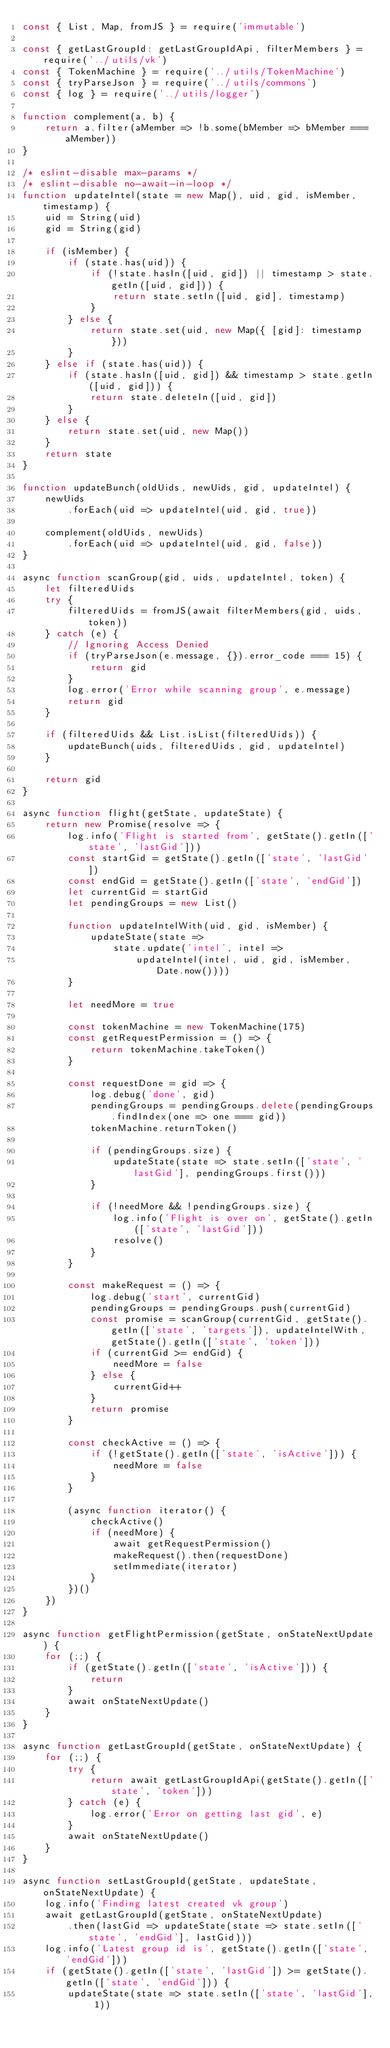<code> <loc_0><loc_0><loc_500><loc_500><_JavaScript_>const { List, Map, fromJS } = require('immutable')

const { getLastGroupId: getLastGroupIdApi, filterMembers } = require('../utils/vk')
const { TokenMachine } = require('../utils/TokenMachine')
const { tryParseJson } = require('../utils/commons')
const { log } = require('../utils/logger')

function complement(a, b) {
    return a.filter(aMember => !b.some(bMember => bMember === aMember))
}

/* eslint-disable max-params */
/* eslint-disable no-await-in-loop */
function updateIntel(state = new Map(), uid, gid, isMember, timestamp) {
    uid = String(uid)
    gid = String(gid)

    if (isMember) {
        if (state.has(uid)) {
            if (!state.hasIn([uid, gid]) || timestamp > state.getIn([uid, gid])) {
                return state.setIn([uid, gid], timestamp)
            }
        } else {
            return state.set(uid, new Map({ [gid]: timestamp }))
        }
    } else if (state.has(uid)) {
        if (state.hasIn([uid, gid]) && timestamp > state.getIn([uid, gid])) {
            return state.deleteIn([uid, gid])
        }
    } else {
        return state.set(uid, new Map())
    }
    return state
}

function updateBunch(oldUids, newUids, gid, updateIntel) {
    newUids
        .forEach(uid => updateIntel(uid, gid, true))

    complement(oldUids, newUids)
        .forEach(uid => updateIntel(uid, gid, false))
}

async function scanGroup(gid, uids, updateIntel, token) {
    let filteredUids
    try {
        filteredUids = fromJS(await filterMembers(gid, uids, token))
    } catch (e) {
        // Ignoring Access Denied
        if (tryParseJson(e.message, {}).error_code === 15) {
            return gid
        }
        log.error('Error while scanning group', e.message)
        return gid
    }

    if (filteredUids && List.isList(filteredUids)) {
        updateBunch(uids, filteredUids, gid, updateIntel)
    }

    return gid
}

async function flight(getState, updateState) {
    return new Promise(resolve => {
        log.info('Flight is started from', getState().getIn(['state', 'lastGid']))
        const startGid = getState().getIn(['state', 'lastGid'])
        const endGid = getState().getIn(['state', 'endGid'])
        let currentGid = startGid
        let pendingGroups = new List()

        function updateIntelWith(uid, gid, isMember) {
            updateState(state =>
                state.update('intel', intel =>
                    updateIntel(intel, uid, gid, isMember, Date.now())))
        }

        let needMore = true

        const tokenMachine = new TokenMachine(175)
        const getRequestPermission = () => {
            return tokenMachine.takeToken()
        }

        const requestDone = gid => {
            log.debug('done', gid)
            pendingGroups = pendingGroups.delete(pendingGroups.findIndex(one => one === gid))
            tokenMachine.returnToken()

            if (pendingGroups.size) {
                updateState(state => state.setIn(['state', 'lastGid'], pendingGroups.first()))
            }

            if (!needMore && !pendingGroups.size) {
                log.info('Flight is over on', getState().getIn(['state', 'lastGid']))
                resolve()
            }
        }

        const makeRequest = () => {
            log.debug('start', currentGid)
            pendingGroups = pendingGroups.push(currentGid)
            const promise = scanGroup(currentGid, getState().getIn(['state', 'targets']), updateIntelWith, getState().getIn(['state', 'token']))
            if (currentGid >= endGid) {
                needMore = false
            } else {
                currentGid++
            }
            return promise
        }

        const checkActive = () => {
            if (!getState().getIn(['state', 'isActive'])) {
                needMore = false
            }
        }

        (async function iterator() {
            checkActive()
            if (needMore) {
                await getRequestPermission()
                makeRequest().then(requestDone)
                setImmediate(iterator)
            }
        })()
    })
}

async function getFlightPermission(getState, onStateNextUpdate) {
    for (;;) {
        if (getState().getIn(['state', 'isActive'])) {
            return
        }
        await onStateNextUpdate()
    }
}

async function getLastGroupId(getState, onStateNextUpdate) {
    for (;;) {
        try {
            return await getLastGroupIdApi(getState().getIn(['state', 'token']))
        } catch (e) {
            log.error('Error on getting last gid', e)
        }
        await onStateNextUpdate()
    }
}

async function setLastGroupId(getState, updateState, onStateNextUpdate) {
    log.info('Finding latest created vk group')
    await getLastGroupId(getState, onStateNextUpdate)
        .then(lastGid => updateState(state => state.setIn(['state', 'endGid'], lastGid)))
    log.info('Latest group id is', getState().getIn(['state', 'endGid']))
    if (getState().getIn(['state', 'lastGid']) >= getState().getIn(['state', 'endGid'])) {
        updateState(state => state.setIn(['state', 'lastGid'], 1))</code> 